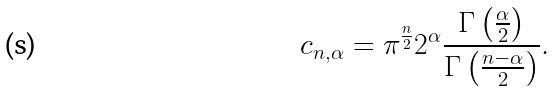<formula> <loc_0><loc_0><loc_500><loc_500>c _ { n , \alpha } = \pi ^ { \frac { n } { 2 } } 2 ^ { \alpha } { \frac { \Gamma \left ( { \frac { \alpha } { 2 } } \right ) } { \Gamma \left ( { \frac { n - \alpha } { 2 } } \right ) } } .</formula> 